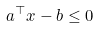Convert formula to latex. <formula><loc_0><loc_0><loc_500><loc_500>a ^ { \top } x - b \leq 0</formula> 